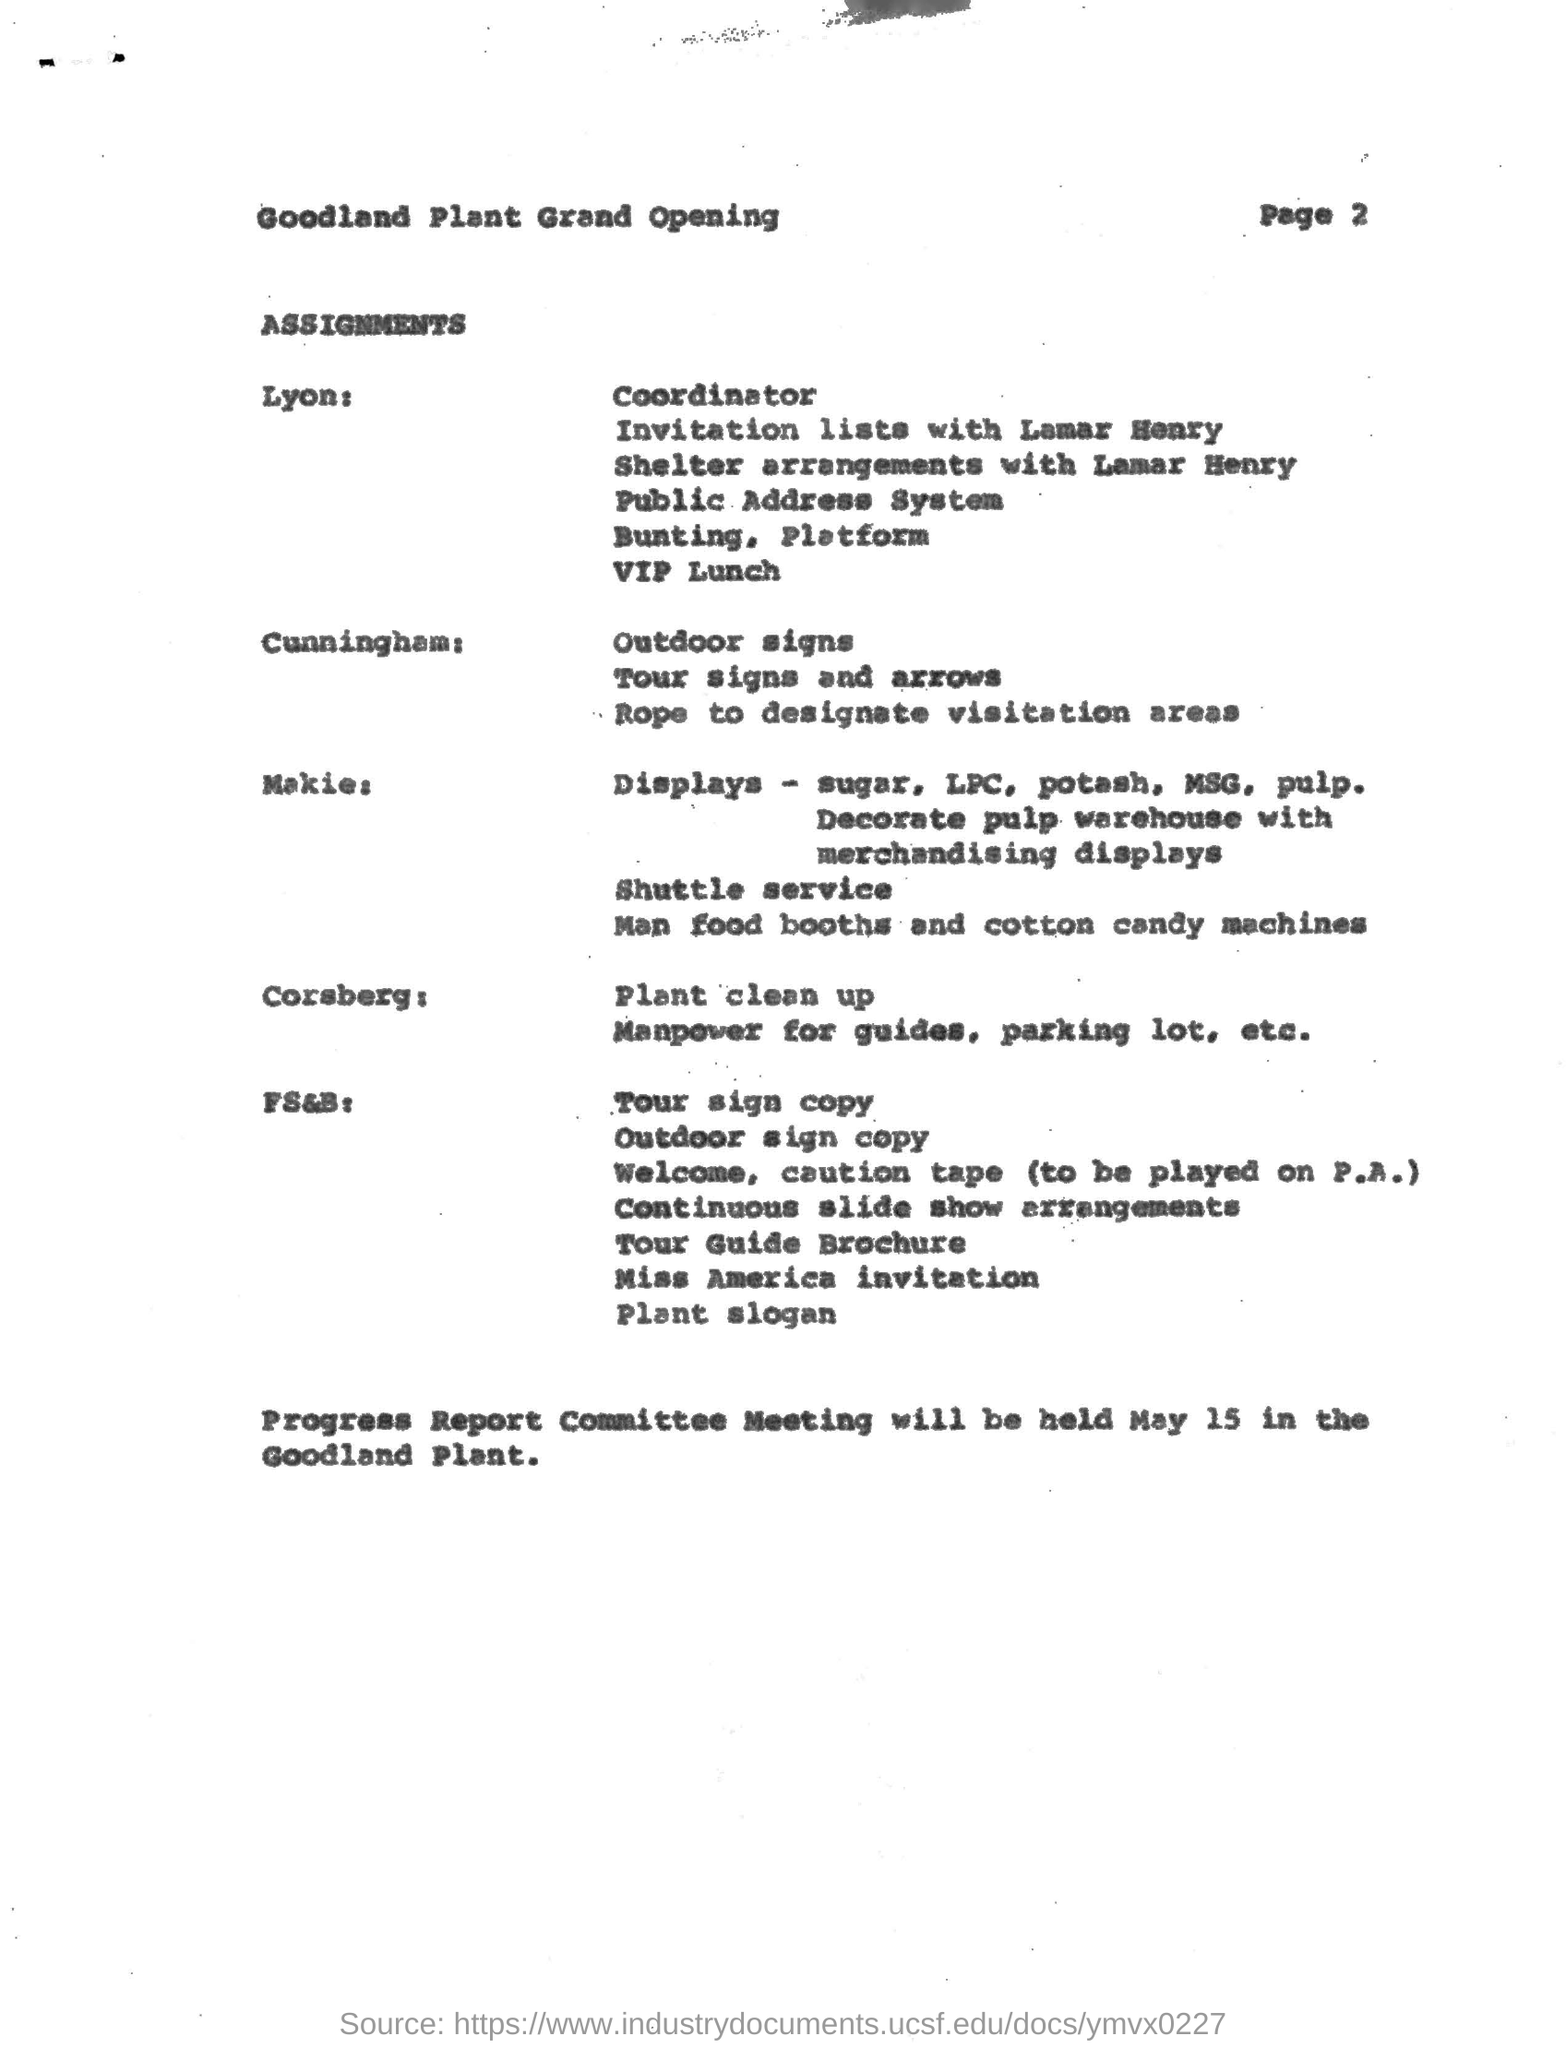Who has the assignment for "Outdoor Signs"?
Your answer should be very brief. Cunningham. Who has the assignment for "Plant Clean up"?
Make the answer very short. Corsberg. Where will be progress report committee meeting be held?
Give a very brief answer. Goodland plant. 